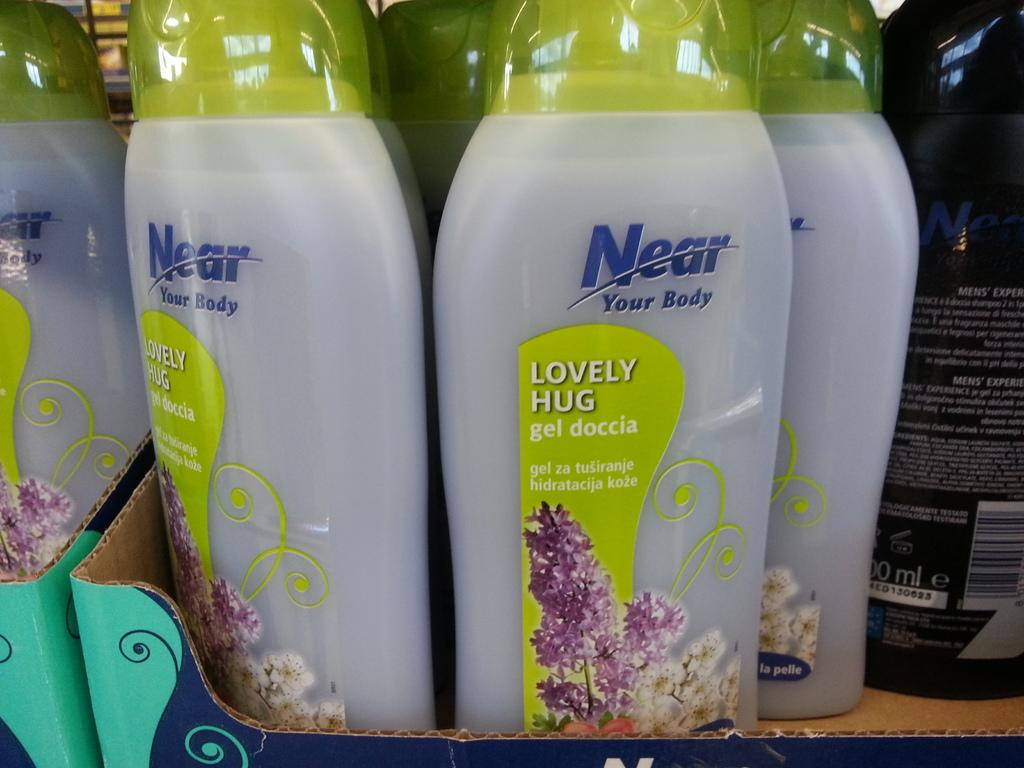<image>
Provide a brief description of the given image. Near your Body Lovely Hug that says Gel Doccia. 